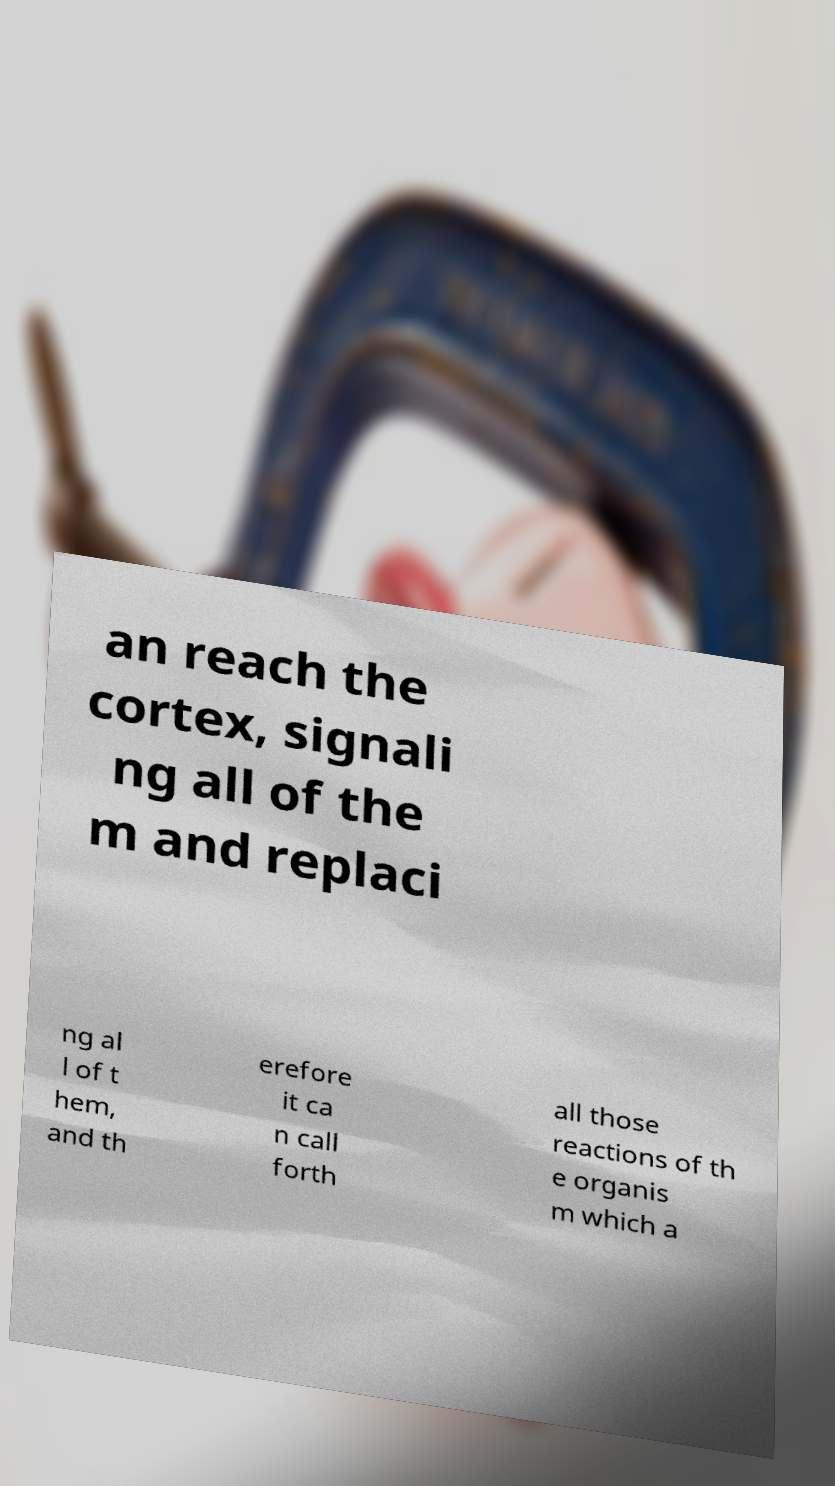I need the written content from this picture converted into text. Can you do that? an reach the cortex, signali ng all of the m and replaci ng al l of t hem, and th erefore it ca n call forth all those reactions of th e organis m which a 